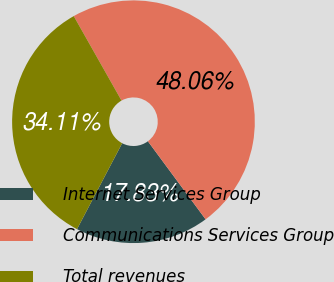Convert chart to OTSL. <chart><loc_0><loc_0><loc_500><loc_500><pie_chart><fcel>Internet Services Group<fcel>Communications Services Group<fcel>Total revenues<nl><fcel>17.83%<fcel>48.06%<fcel>34.11%<nl></chart> 